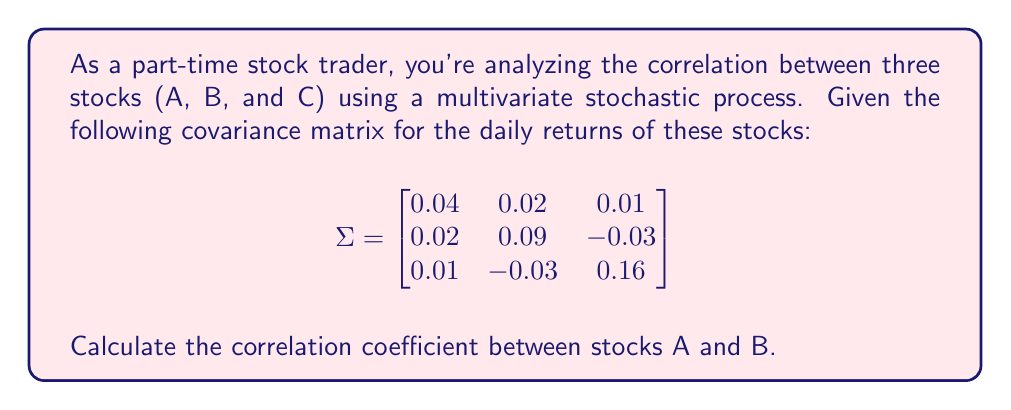Solve this math problem. To calculate the correlation coefficient between stocks A and B, we'll follow these steps:

1. Recall the formula for the correlation coefficient:
   $$\rho_{AB} = \frac{\text{Cov}(A,B)}{\sigma_A \sigma_B}$$
   where $\text{Cov}(A,B)$ is the covariance between A and B, and $\sigma_A$ and $\sigma_B$ are the standard deviations of A and B respectively.

2. From the given covariance matrix $\Sigma$:
   - $\text{Cov}(A,B) = 0.02$
   - $\text{Var}(A) = 0.04$
   - $\text{Var}(B) = 0.09$

3. Calculate the standard deviations:
   $\sigma_A = \sqrt{\text{Var}(A)} = \sqrt{0.04} = 0.2$
   $\sigma_B = \sqrt{\text{Var}(B)} = \sqrt{0.09} = 0.3$

4. Apply the correlation coefficient formula:
   $$\rho_{AB} = \frac{0.02}{0.2 \times 0.3} = \frac{0.02}{0.06} = \frac{1}{3} \approx 0.3333$$

Thus, the correlation coefficient between stocks A and B is approximately 0.3333 or 1/3.
Answer: $\frac{1}{3}$ or approximately 0.3333 